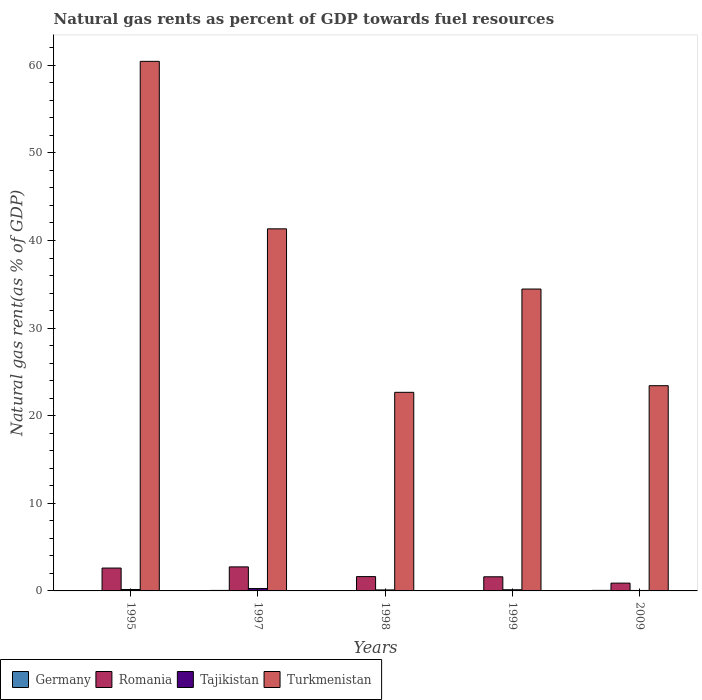How many different coloured bars are there?
Your answer should be compact. 4. Are the number of bars on each tick of the X-axis equal?
Provide a short and direct response. Yes. How many bars are there on the 4th tick from the right?
Your answer should be very brief. 4. What is the label of the 1st group of bars from the left?
Ensure brevity in your answer.  1995. In how many cases, is the number of bars for a given year not equal to the number of legend labels?
Keep it short and to the point. 0. What is the natural gas rent in Tajikistan in 2009?
Provide a short and direct response. 0.05. Across all years, what is the maximum natural gas rent in Tajikistan?
Give a very brief answer. 0.27. Across all years, what is the minimum natural gas rent in Romania?
Offer a very short reply. 0.89. In which year was the natural gas rent in Turkmenistan minimum?
Keep it short and to the point. 1998. What is the total natural gas rent in Germany in the graph?
Your response must be concise. 0.24. What is the difference between the natural gas rent in Tajikistan in 1999 and that in 2009?
Provide a short and direct response. 0.08. What is the difference between the natural gas rent in Turkmenistan in 1997 and the natural gas rent in Romania in 2009?
Your response must be concise. 40.44. What is the average natural gas rent in Germany per year?
Keep it short and to the point. 0.05. In the year 1998, what is the difference between the natural gas rent in Tajikistan and natural gas rent in Turkmenistan?
Provide a short and direct response. -22.56. In how many years, is the natural gas rent in Tajikistan greater than 40 %?
Make the answer very short. 0. What is the ratio of the natural gas rent in Turkmenistan in 1995 to that in 2009?
Make the answer very short. 2.58. Is the difference between the natural gas rent in Tajikistan in 1995 and 2009 greater than the difference between the natural gas rent in Turkmenistan in 1995 and 2009?
Give a very brief answer. No. What is the difference between the highest and the second highest natural gas rent in Tajikistan?
Make the answer very short. 0.11. What is the difference between the highest and the lowest natural gas rent in Romania?
Your answer should be very brief. 1.85. In how many years, is the natural gas rent in Turkmenistan greater than the average natural gas rent in Turkmenistan taken over all years?
Make the answer very short. 2. Is the sum of the natural gas rent in Romania in 1997 and 1999 greater than the maximum natural gas rent in Tajikistan across all years?
Offer a terse response. Yes. Is it the case that in every year, the sum of the natural gas rent in Germany and natural gas rent in Tajikistan is greater than the sum of natural gas rent in Romania and natural gas rent in Turkmenistan?
Your answer should be very brief. No. What does the 3rd bar from the right in 1997 represents?
Your answer should be compact. Romania. Are all the bars in the graph horizontal?
Provide a succinct answer. No. How many years are there in the graph?
Keep it short and to the point. 5. Are the values on the major ticks of Y-axis written in scientific E-notation?
Your answer should be compact. No. Does the graph contain grids?
Your answer should be very brief. No. How many legend labels are there?
Offer a very short reply. 4. What is the title of the graph?
Your answer should be compact. Natural gas rents as percent of GDP towards fuel resources. What is the label or title of the Y-axis?
Your answer should be very brief. Natural gas rent(as % of GDP). What is the Natural gas rent(as % of GDP) of Germany in 1995?
Your answer should be very brief. 0.04. What is the Natural gas rent(as % of GDP) of Romania in 1995?
Make the answer very short. 2.61. What is the Natural gas rent(as % of GDP) in Tajikistan in 1995?
Your answer should be compact. 0.16. What is the Natural gas rent(as % of GDP) in Turkmenistan in 1995?
Ensure brevity in your answer.  60.45. What is the Natural gas rent(as % of GDP) in Germany in 1997?
Your response must be concise. 0.06. What is the Natural gas rent(as % of GDP) in Romania in 1997?
Offer a terse response. 2.74. What is the Natural gas rent(as % of GDP) of Tajikistan in 1997?
Your answer should be very brief. 0.27. What is the Natural gas rent(as % of GDP) in Turkmenistan in 1997?
Your response must be concise. 41.33. What is the Natural gas rent(as % of GDP) in Germany in 1998?
Keep it short and to the point. 0.04. What is the Natural gas rent(as % of GDP) of Romania in 1998?
Give a very brief answer. 1.64. What is the Natural gas rent(as % of GDP) in Tajikistan in 1998?
Your response must be concise. 0.11. What is the Natural gas rent(as % of GDP) in Turkmenistan in 1998?
Your response must be concise. 22.67. What is the Natural gas rent(as % of GDP) of Germany in 1999?
Ensure brevity in your answer.  0.04. What is the Natural gas rent(as % of GDP) of Romania in 1999?
Keep it short and to the point. 1.61. What is the Natural gas rent(as % of GDP) of Tajikistan in 1999?
Your response must be concise. 0.13. What is the Natural gas rent(as % of GDP) in Turkmenistan in 1999?
Keep it short and to the point. 34.46. What is the Natural gas rent(as % of GDP) in Germany in 2009?
Offer a very short reply. 0.06. What is the Natural gas rent(as % of GDP) in Romania in 2009?
Provide a succinct answer. 0.89. What is the Natural gas rent(as % of GDP) of Tajikistan in 2009?
Your response must be concise. 0.05. What is the Natural gas rent(as % of GDP) of Turkmenistan in 2009?
Make the answer very short. 23.42. Across all years, what is the maximum Natural gas rent(as % of GDP) in Germany?
Your response must be concise. 0.06. Across all years, what is the maximum Natural gas rent(as % of GDP) in Romania?
Ensure brevity in your answer.  2.74. Across all years, what is the maximum Natural gas rent(as % of GDP) of Tajikistan?
Your answer should be compact. 0.27. Across all years, what is the maximum Natural gas rent(as % of GDP) of Turkmenistan?
Your answer should be very brief. 60.45. Across all years, what is the minimum Natural gas rent(as % of GDP) in Germany?
Offer a very short reply. 0.04. Across all years, what is the minimum Natural gas rent(as % of GDP) in Romania?
Provide a short and direct response. 0.89. Across all years, what is the minimum Natural gas rent(as % of GDP) in Tajikistan?
Keep it short and to the point. 0.05. Across all years, what is the minimum Natural gas rent(as % of GDP) in Turkmenistan?
Keep it short and to the point. 22.67. What is the total Natural gas rent(as % of GDP) of Germany in the graph?
Your answer should be very brief. 0.24. What is the total Natural gas rent(as % of GDP) of Romania in the graph?
Make the answer very short. 9.49. What is the total Natural gas rent(as % of GDP) in Tajikistan in the graph?
Your response must be concise. 0.73. What is the total Natural gas rent(as % of GDP) of Turkmenistan in the graph?
Keep it short and to the point. 182.33. What is the difference between the Natural gas rent(as % of GDP) of Germany in 1995 and that in 1997?
Provide a short and direct response. -0.02. What is the difference between the Natural gas rent(as % of GDP) in Romania in 1995 and that in 1997?
Your answer should be compact. -0.13. What is the difference between the Natural gas rent(as % of GDP) of Tajikistan in 1995 and that in 1997?
Your response must be concise. -0.11. What is the difference between the Natural gas rent(as % of GDP) of Turkmenistan in 1995 and that in 1997?
Ensure brevity in your answer.  19.12. What is the difference between the Natural gas rent(as % of GDP) in Germany in 1995 and that in 1998?
Give a very brief answer. -0.01. What is the difference between the Natural gas rent(as % of GDP) of Romania in 1995 and that in 1998?
Ensure brevity in your answer.  0.98. What is the difference between the Natural gas rent(as % of GDP) of Tajikistan in 1995 and that in 1998?
Give a very brief answer. 0.05. What is the difference between the Natural gas rent(as % of GDP) of Turkmenistan in 1995 and that in 1998?
Your answer should be compact. 37.78. What is the difference between the Natural gas rent(as % of GDP) in Germany in 1995 and that in 1999?
Give a very brief answer. -0. What is the difference between the Natural gas rent(as % of GDP) of Tajikistan in 1995 and that in 1999?
Ensure brevity in your answer.  0.03. What is the difference between the Natural gas rent(as % of GDP) of Turkmenistan in 1995 and that in 1999?
Your answer should be compact. 25.99. What is the difference between the Natural gas rent(as % of GDP) in Germany in 1995 and that in 2009?
Provide a succinct answer. -0.02. What is the difference between the Natural gas rent(as % of GDP) in Romania in 1995 and that in 2009?
Your answer should be very brief. 1.72. What is the difference between the Natural gas rent(as % of GDP) in Tajikistan in 1995 and that in 2009?
Your response must be concise. 0.11. What is the difference between the Natural gas rent(as % of GDP) in Turkmenistan in 1995 and that in 2009?
Provide a short and direct response. 37.02. What is the difference between the Natural gas rent(as % of GDP) in Germany in 1997 and that in 1998?
Give a very brief answer. 0.02. What is the difference between the Natural gas rent(as % of GDP) in Romania in 1997 and that in 1998?
Your answer should be very brief. 1.11. What is the difference between the Natural gas rent(as % of GDP) of Tajikistan in 1997 and that in 1998?
Your answer should be compact. 0.16. What is the difference between the Natural gas rent(as % of GDP) in Turkmenistan in 1997 and that in 1998?
Your answer should be compact. 18.66. What is the difference between the Natural gas rent(as % of GDP) in Germany in 1997 and that in 1999?
Give a very brief answer. 0.02. What is the difference between the Natural gas rent(as % of GDP) in Romania in 1997 and that in 1999?
Give a very brief answer. 1.13. What is the difference between the Natural gas rent(as % of GDP) of Tajikistan in 1997 and that in 1999?
Give a very brief answer. 0.14. What is the difference between the Natural gas rent(as % of GDP) of Turkmenistan in 1997 and that in 1999?
Make the answer very short. 6.87. What is the difference between the Natural gas rent(as % of GDP) of Germany in 1997 and that in 2009?
Your response must be concise. -0. What is the difference between the Natural gas rent(as % of GDP) of Romania in 1997 and that in 2009?
Give a very brief answer. 1.85. What is the difference between the Natural gas rent(as % of GDP) in Tajikistan in 1997 and that in 2009?
Ensure brevity in your answer.  0.22. What is the difference between the Natural gas rent(as % of GDP) in Turkmenistan in 1997 and that in 2009?
Your response must be concise. 17.9. What is the difference between the Natural gas rent(as % of GDP) in Germany in 1998 and that in 1999?
Offer a very short reply. 0. What is the difference between the Natural gas rent(as % of GDP) of Romania in 1998 and that in 1999?
Your answer should be very brief. 0.02. What is the difference between the Natural gas rent(as % of GDP) in Tajikistan in 1998 and that in 1999?
Provide a short and direct response. -0.02. What is the difference between the Natural gas rent(as % of GDP) of Turkmenistan in 1998 and that in 1999?
Give a very brief answer. -11.79. What is the difference between the Natural gas rent(as % of GDP) of Germany in 1998 and that in 2009?
Provide a succinct answer. -0.02. What is the difference between the Natural gas rent(as % of GDP) in Romania in 1998 and that in 2009?
Make the answer very short. 0.74. What is the difference between the Natural gas rent(as % of GDP) in Tajikistan in 1998 and that in 2009?
Give a very brief answer. 0.06. What is the difference between the Natural gas rent(as % of GDP) of Turkmenistan in 1998 and that in 2009?
Offer a very short reply. -0.76. What is the difference between the Natural gas rent(as % of GDP) in Germany in 1999 and that in 2009?
Give a very brief answer. -0.02. What is the difference between the Natural gas rent(as % of GDP) in Romania in 1999 and that in 2009?
Make the answer very short. 0.72. What is the difference between the Natural gas rent(as % of GDP) in Tajikistan in 1999 and that in 2009?
Give a very brief answer. 0.08. What is the difference between the Natural gas rent(as % of GDP) of Turkmenistan in 1999 and that in 2009?
Provide a short and direct response. 11.03. What is the difference between the Natural gas rent(as % of GDP) in Germany in 1995 and the Natural gas rent(as % of GDP) in Romania in 1997?
Your answer should be very brief. -2.71. What is the difference between the Natural gas rent(as % of GDP) in Germany in 1995 and the Natural gas rent(as % of GDP) in Tajikistan in 1997?
Provide a succinct answer. -0.23. What is the difference between the Natural gas rent(as % of GDP) of Germany in 1995 and the Natural gas rent(as % of GDP) of Turkmenistan in 1997?
Your answer should be very brief. -41.29. What is the difference between the Natural gas rent(as % of GDP) in Romania in 1995 and the Natural gas rent(as % of GDP) in Tajikistan in 1997?
Offer a terse response. 2.34. What is the difference between the Natural gas rent(as % of GDP) of Romania in 1995 and the Natural gas rent(as % of GDP) of Turkmenistan in 1997?
Offer a terse response. -38.72. What is the difference between the Natural gas rent(as % of GDP) in Tajikistan in 1995 and the Natural gas rent(as % of GDP) in Turkmenistan in 1997?
Your response must be concise. -41.17. What is the difference between the Natural gas rent(as % of GDP) in Germany in 1995 and the Natural gas rent(as % of GDP) in Romania in 1998?
Your answer should be compact. -1.6. What is the difference between the Natural gas rent(as % of GDP) of Germany in 1995 and the Natural gas rent(as % of GDP) of Tajikistan in 1998?
Offer a terse response. -0.08. What is the difference between the Natural gas rent(as % of GDP) of Germany in 1995 and the Natural gas rent(as % of GDP) of Turkmenistan in 1998?
Your answer should be very brief. -22.63. What is the difference between the Natural gas rent(as % of GDP) of Romania in 1995 and the Natural gas rent(as % of GDP) of Tajikistan in 1998?
Your answer should be very brief. 2.5. What is the difference between the Natural gas rent(as % of GDP) of Romania in 1995 and the Natural gas rent(as % of GDP) of Turkmenistan in 1998?
Offer a very short reply. -20.06. What is the difference between the Natural gas rent(as % of GDP) in Tajikistan in 1995 and the Natural gas rent(as % of GDP) in Turkmenistan in 1998?
Offer a terse response. -22.51. What is the difference between the Natural gas rent(as % of GDP) of Germany in 1995 and the Natural gas rent(as % of GDP) of Romania in 1999?
Your response must be concise. -1.58. What is the difference between the Natural gas rent(as % of GDP) in Germany in 1995 and the Natural gas rent(as % of GDP) in Tajikistan in 1999?
Offer a very short reply. -0.09. What is the difference between the Natural gas rent(as % of GDP) in Germany in 1995 and the Natural gas rent(as % of GDP) in Turkmenistan in 1999?
Offer a terse response. -34.42. What is the difference between the Natural gas rent(as % of GDP) of Romania in 1995 and the Natural gas rent(as % of GDP) of Tajikistan in 1999?
Your answer should be compact. 2.48. What is the difference between the Natural gas rent(as % of GDP) of Romania in 1995 and the Natural gas rent(as % of GDP) of Turkmenistan in 1999?
Your answer should be compact. -31.85. What is the difference between the Natural gas rent(as % of GDP) in Tajikistan in 1995 and the Natural gas rent(as % of GDP) in Turkmenistan in 1999?
Offer a very short reply. -34.3. What is the difference between the Natural gas rent(as % of GDP) in Germany in 1995 and the Natural gas rent(as % of GDP) in Romania in 2009?
Provide a short and direct response. -0.85. What is the difference between the Natural gas rent(as % of GDP) of Germany in 1995 and the Natural gas rent(as % of GDP) of Tajikistan in 2009?
Provide a short and direct response. -0.02. What is the difference between the Natural gas rent(as % of GDP) in Germany in 1995 and the Natural gas rent(as % of GDP) in Turkmenistan in 2009?
Ensure brevity in your answer.  -23.39. What is the difference between the Natural gas rent(as % of GDP) in Romania in 1995 and the Natural gas rent(as % of GDP) in Tajikistan in 2009?
Provide a succinct answer. 2.56. What is the difference between the Natural gas rent(as % of GDP) of Romania in 1995 and the Natural gas rent(as % of GDP) of Turkmenistan in 2009?
Ensure brevity in your answer.  -20.81. What is the difference between the Natural gas rent(as % of GDP) of Tajikistan in 1995 and the Natural gas rent(as % of GDP) of Turkmenistan in 2009?
Keep it short and to the point. -23.27. What is the difference between the Natural gas rent(as % of GDP) of Germany in 1997 and the Natural gas rent(as % of GDP) of Romania in 1998?
Give a very brief answer. -1.58. What is the difference between the Natural gas rent(as % of GDP) of Germany in 1997 and the Natural gas rent(as % of GDP) of Tajikistan in 1998?
Offer a terse response. -0.06. What is the difference between the Natural gas rent(as % of GDP) of Germany in 1997 and the Natural gas rent(as % of GDP) of Turkmenistan in 1998?
Offer a very short reply. -22.61. What is the difference between the Natural gas rent(as % of GDP) of Romania in 1997 and the Natural gas rent(as % of GDP) of Tajikistan in 1998?
Ensure brevity in your answer.  2.63. What is the difference between the Natural gas rent(as % of GDP) of Romania in 1997 and the Natural gas rent(as % of GDP) of Turkmenistan in 1998?
Your answer should be very brief. -19.93. What is the difference between the Natural gas rent(as % of GDP) in Tajikistan in 1997 and the Natural gas rent(as % of GDP) in Turkmenistan in 1998?
Your answer should be compact. -22.4. What is the difference between the Natural gas rent(as % of GDP) in Germany in 1997 and the Natural gas rent(as % of GDP) in Romania in 1999?
Keep it short and to the point. -1.55. What is the difference between the Natural gas rent(as % of GDP) of Germany in 1997 and the Natural gas rent(as % of GDP) of Tajikistan in 1999?
Give a very brief answer. -0.07. What is the difference between the Natural gas rent(as % of GDP) in Germany in 1997 and the Natural gas rent(as % of GDP) in Turkmenistan in 1999?
Make the answer very short. -34.4. What is the difference between the Natural gas rent(as % of GDP) in Romania in 1997 and the Natural gas rent(as % of GDP) in Tajikistan in 1999?
Your response must be concise. 2.61. What is the difference between the Natural gas rent(as % of GDP) in Romania in 1997 and the Natural gas rent(as % of GDP) in Turkmenistan in 1999?
Keep it short and to the point. -31.71. What is the difference between the Natural gas rent(as % of GDP) of Tajikistan in 1997 and the Natural gas rent(as % of GDP) of Turkmenistan in 1999?
Provide a short and direct response. -34.19. What is the difference between the Natural gas rent(as % of GDP) of Germany in 1997 and the Natural gas rent(as % of GDP) of Romania in 2009?
Give a very brief answer. -0.83. What is the difference between the Natural gas rent(as % of GDP) of Germany in 1997 and the Natural gas rent(as % of GDP) of Tajikistan in 2009?
Offer a terse response. 0.01. What is the difference between the Natural gas rent(as % of GDP) of Germany in 1997 and the Natural gas rent(as % of GDP) of Turkmenistan in 2009?
Provide a short and direct response. -23.37. What is the difference between the Natural gas rent(as % of GDP) in Romania in 1997 and the Natural gas rent(as % of GDP) in Tajikistan in 2009?
Offer a very short reply. 2.69. What is the difference between the Natural gas rent(as % of GDP) in Romania in 1997 and the Natural gas rent(as % of GDP) in Turkmenistan in 2009?
Offer a terse response. -20.68. What is the difference between the Natural gas rent(as % of GDP) of Tajikistan in 1997 and the Natural gas rent(as % of GDP) of Turkmenistan in 2009?
Your answer should be compact. -23.15. What is the difference between the Natural gas rent(as % of GDP) of Germany in 1998 and the Natural gas rent(as % of GDP) of Romania in 1999?
Ensure brevity in your answer.  -1.57. What is the difference between the Natural gas rent(as % of GDP) in Germany in 1998 and the Natural gas rent(as % of GDP) in Tajikistan in 1999?
Provide a succinct answer. -0.09. What is the difference between the Natural gas rent(as % of GDP) in Germany in 1998 and the Natural gas rent(as % of GDP) in Turkmenistan in 1999?
Keep it short and to the point. -34.42. What is the difference between the Natural gas rent(as % of GDP) in Romania in 1998 and the Natural gas rent(as % of GDP) in Tajikistan in 1999?
Ensure brevity in your answer.  1.5. What is the difference between the Natural gas rent(as % of GDP) of Romania in 1998 and the Natural gas rent(as % of GDP) of Turkmenistan in 1999?
Offer a very short reply. -32.82. What is the difference between the Natural gas rent(as % of GDP) of Tajikistan in 1998 and the Natural gas rent(as % of GDP) of Turkmenistan in 1999?
Your answer should be compact. -34.34. What is the difference between the Natural gas rent(as % of GDP) of Germany in 1998 and the Natural gas rent(as % of GDP) of Romania in 2009?
Offer a terse response. -0.85. What is the difference between the Natural gas rent(as % of GDP) of Germany in 1998 and the Natural gas rent(as % of GDP) of Tajikistan in 2009?
Offer a very short reply. -0.01. What is the difference between the Natural gas rent(as % of GDP) in Germany in 1998 and the Natural gas rent(as % of GDP) in Turkmenistan in 2009?
Your answer should be very brief. -23.38. What is the difference between the Natural gas rent(as % of GDP) in Romania in 1998 and the Natural gas rent(as % of GDP) in Tajikistan in 2009?
Keep it short and to the point. 1.58. What is the difference between the Natural gas rent(as % of GDP) of Romania in 1998 and the Natural gas rent(as % of GDP) of Turkmenistan in 2009?
Offer a terse response. -21.79. What is the difference between the Natural gas rent(as % of GDP) of Tajikistan in 1998 and the Natural gas rent(as % of GDP) of Turkmenistan in 2009?
Offer a very short reply. -23.31. What is the difference between the Natural gas rent(as % of GDP) of Germany in 1999 and the Natural gas rent(as % of GDP) of Romania in 2009?
Your response must be concise. -0.85. What is the difference between the Natural gas rent(as % of GDP) in Germany in 1999 and the Natural gas rent(as % of GDP) in Tajikistan in 2009?
Keep it short and to the point. -0.01. What is the difference between the Natural gas rent(as % of GDP) of Germany in 1999 and the Natural gas rent(as % of GDP) of Turkmenistan in 2009?
Your answer should be very brief. -23.39. What is the difference between the Natural gas rent(as % of GDP) of Romania in 1999 and the Natural gas rent(as % of GDP) of Tajikistan in 2009?
Ensure brevity in your answer.  1.56. What is the difference between the Natural gas rent(as % of GDP) of Romania in 1999 and the Natural gas rent(as % of GDP) of Turkmenistan in 2009?
Make the answer very short. -21.81. What is the difference between the Natural gas rent(as % of GDP) of Tajikistan in 1999 and the Natural gas rent(as % of GDP) of Turkmenistan in 2009?
Your answer should be very brief. -23.29. What is the average Natural gas rent(as % of GDP) in Germany per year?
Your answer should be compact. 0.05. What is the average Natural gas rent(as % of GDP) in Romania per year?
Provide a succinct answer. 1.9. What is the average Natural gas rent(as % of GDP) in Tajikistan per year?
Provide a succinct answer. 0.15. What is the average Natural gas rent(as % of GDP) of Turkmenistan per year?
Your response must be concise. 36.47. In the year 1995, what is the difference between the Natural gas rent(as % of GDP) in Germany and Natural gas rent(as % of GDP) in Romania?
Offer a terse response. -2.57. In the year 1995, what is the difference between the Natural gas rent(as % of GDP) of Germany and Natural gas rent(as % of GDP) of Tajikistan?
Your answer should be very brief. -0.12. In the year 1995, what is the difference between the Natural gas rent(as % of GDP) in Germany and Natural gas rent(as % of GDP) in Turkmenistan?
Your response must be concise. -60.41. In the year 1995, what is the difference between the Natural gas rent(as % of GDP) of Romania and Natural gas rent(as % of GDP) of Tajikistan?
Your answer should be compact. 2.45. In the year 1995, what is the difference between the Natural gas rent(as % of GDP) of Romania and Natural gas rent(as % of GDP) of Turkmenistan?
Your answer should be compact. -57.84. In the year 1995, what is the difference between the Natural gas rent(as % of GDP) of Tajikistan and Natural gas rent(as % of GDP) of Turkmenistan?
Make the answer very short. -60.29. In the year 1997, what is the difference between the Natural gas rent(as % of GDP) of Germany and Natural gas rent(as % of GDP) of Romania?
Provide a succinct answer. -2.69. In the year 1997, what is the difference between the Natural gas rent(as % of GDP) in Germany and Natural gas rent(as % of GDP) in Tajikistan?
Your answer should be compact. -0.21. In the year 1997, what is the difference between the Natural gas rent(as % of GDP) of Germany and Natural gas rent(as % of GDP) of Turkmenistan?
Your answer should be very brief. -41.27. In the year 1997, what is the difference between the Natural gas rent(as % of GDP) of Romania and Natural gas rent(as % of GDP) of Tajikistan?
Keep it short and to the point. 2.47. In the year 1997, what is the difference between the Natural gas rent(as % of GDP) in Romania and Natural gas rent(as % of GDP) in Turkmenistan?
Keep it short and to the point. -38.59. In the year 1997, what is the difference between the Natural gas rent(as % of GDP) in Tajikistan and Natural gas rent(as % of GDP) in Turkmenistan?
Your answer should be compact. -41.06. In the year 1998, what is the difference between the Natural gas rent(as % of GDP) in Germany and Natural gas rent(as % of GDP) in Romania?
Make the answer very short. -1.59. In the year 1998, what is the difference between the Natural gas rent(as % of GDP) in Germany and Natural gas rent(as % of GDP) in Tajikistan?
Keep it short and to the point. -0.07. In the year 1998, what is the difference between the Natural gas rent(as % of GDP) in Germany and Natural gas rent(as % of GDP) in Turkmenistan?
Your answer should be very brief. -22.63. In the year 1998, what is the difference between the Natural gas rent(as % of GDP) of Romania and Natural gas rent(as % of GDP) of Tajikistan?
Provide a short and direct response. 1.52. In the year 1998, what is the difference between the Natural gas rent(as % of GDP) in Romania and Natural gas rent(as % of GDP) in Turkmenistan?
Your response must be concise. -21.03. In the year 1998, what is the difference between the Natural gas rent(as % of GDP) in Tajikistan and Natural gas rent(as % of GDP) in Turkmenistan?
Your answer should be very brief. -22.56. In the year 1999, what is the difference between the Natural gas rent(as % of GDP) of Germany and Natural gas rent(as % of GDP) of Romania?
Make the answer very short. -1.57. In the year 1999, what is the difference between the Natural gas rent(as % of GDP) of Germany and Natural gas rent(as % of GDP) of Tajikistan?
Keep it short and to the point. -0.09. In the year 1999, what is the difference between the Natural gas rent(as % of GDP) in Germany and Natural gas rent(as % of GDP) in Turkmenistan?
Provide a short and direct response. -34.42. In the year 1999, what is the difference between the Natural gas rent(as % of GDP) of Romania and Natural gas rent(as % of GDP) of Tajikistan?
Make the answer very short. 1.48. In the year 1999, what is the difference between the Natural gas rent(as % of GDP) in Romania and Natural gas rent(as % of GDP) in Turkmenistan?
Provide a succinct answer. -32.85. In the year 1999, what is the difference between the Natural gas rent(as % of GDP) of Tajikistan and Natural gas rent(as % of GDP) of Turkmenistan?
Offer a very short reply. -34.33. In the year 2009, what is the difference between the Natural gas rent(as % of GDP) in Germany and Natural gas rent(as % of GDP) in Romania?
Provide a short and direct response. -0.83. In the year 2009, what is the difference between the Natural gas rent(as % of GDP) of Germany and Natural gas rent(as % of GDP) of Tajikistan?
Offer a very short reply. 0.01. In the year 2009, what is the difference between the Natural gas rent(as % of GDP) in Germany and Natural gas rent(as % of GDP) in Turkmenistan?
Offer a very short reply. -23.36. In the year 2009, what is the difference between the Natural gas rent(as % of GDP) in Romania and Natural gas rent(as % of GDP) in Tajikistan?
Ensure brevity in your answer.  0.84. In the year 2009, what is the difference between the Natural gas rent(as % of GDP) in Romania and Natural gas rent(as % of GDP) in Turkmenistan?
Your answer should be very brief. -22.53. In the year 2009, what is the difference between the Natural gas rent(as % of GDP) in Tajikistan and Natural gas rent(as % of GDP) in Turkmenistan?
Provide a succinct answer. -23.37. What is the ratio of the Natural gas rent(as % of GDP) of Germany in 1995 to that in 1997?
Keep it short and to the point. 0.64. What is the ratio of the Natural gas rent(as % of GDP) of Romania in 1995 to that in 1997?
Keep it short and to the point. 0.95. What is the ratio of the Natural gas rent(as % of GDP) of Tajikistan in 1995 to that in 1997?
Keep it short and to the point. 0.58. What is the ratio of the Natural gas rent(as % of GDP) of Turkmenistan in 1995 to that in 1997?
Your answer should be very brief. 1.46. What is the ratio of the Natural gas rent(as % of GDP) in Germany in 1995 to that in 1998?
Give a very brief answer. 0.87. What is the ratio of the Natural gas rent(as % of GDP) in Romania in 1995 to that in 1998?
Your answer should be compact. 1.6. What is the ratio of the Natural gas rent(as % of GDP) of Tajikistan in 1995 to that in 1998?
Give a very brief answer. 1.4. What is the ratio of the Natural gas rent(as % of GDP) in Turkmenistan in 1995 to that in 1998?
Provide a short and direct response. 2.67. What is the ratio of the Natural gas rent(as % of GDP) in Germany in 1995 to that in 1999?
Your answer should be very brief. 0.96. What is the ratio of the Natural gas rent(as % of GDP) in Romania in 1995 to that in 1999?
Your response must be concise. 1.62. What is the ratio of the Natural gas rent(as % of GDP) in Tajikistan in 1995 to that in 1999?
Make the answer very short. 1.21. What is the ratio of the Natural gas rent(as % of GDP) of Turkmenistan in 1995 to that in 1999?
Provide a succinct answer. 1.75. What is the ratio of the Natural gas rent(as % of GDP) of Germany in 1995 to that in 2009?
Keep it short and to the point. 0.6. What is the ratio of the Natural gas rent(as % of GDP) of Romania in 1995 to that in 2009?
Give a very brief answer. 2.93. What is the ratio of the Natural gas rent(as % of GDP) in Tajikistan in 1995 to that in 2009?
Provide a short and direct response. 3.03. What is the ratio of the Natural gas rent(as % of GDP) in Turkmenistan in 1995 to that in 2009?
Offer a terse response. 2.58. What is the ratio of the Natural gas rent(as % of GDP) in Germany in 1997 to that in 1998?
Keep it short and to the point. 1.37. What is the ratio of the Natural gas rent(as % of GDP) of Romania in 1997 to that in 1998?
Offer a terse response. 1.68. What is the ratio of the Natural gas rent(as % of GDP) in Tajikistan in 1997 to that in 1998?
Ensure brevity in your answer.  2.4. What is the ratio of the Natural gas rent(as % of GDP) of Turkmenistan in 1997 to that in 1998?
Your answer should be compact. 1.82. What is the ratio of the Natural gas rent(as % of GDP) of Germany in 1997 to that in 1999?
Offer a terse response. 1.51. What is the ratio of the Natural gas rent(as % of GDP) of Romania in 1997 to that in 1999?
Offer a very short reply. 1.7. What is the ratio of the Natural gas rent(as % of GDP) in Tajikistan in 1997 to that in 1999?
Your answer should be compact. 2.07. What is the ratio of the Natural gas rent(as % of GDP) of Turkmenistan in 1997 to that in 1999?
Offer a terse response. 1.2. What is the ratio of the Natural gas rent(as % of GDP) in Germany in 1997 to that in 2009?
Ensure brevity in your answer.  0.95. What is the ratio of the Natural gas rent(as % of GDP) in Romania in 1997 to that in 2009?
Your response must be concise. 3.08. What is the ratio of the Natural gas rent(as % of GDP) of Tajikistan in 1997 to that in 2009?
Your answer should be very brief. 5.18. What is the ratio of the Natural gas rent(as % of GDP) of Turkmenistan in 1997 to that in 2009?
Offer a very short reply. 1.76. What is the ratio of the Natural gas rent(as % of GDP) of Germany in 1998 to that in 1999?
Keep it short and to the point. 1.1. What is the ratio of the Natural gas rent(as % of GDP) of Romania in 1998 to that in 1999?
Your answer should be compact. 1.01. What is the ratio of the Natural gas rent(as % of GDP) in Tajikistan in 1998 to that in 1999?
Offer a very short reply. 0.86. What is the ratio of the Natural gas rent(as % of GDP) of Turkmenistan in 1998 to that in 1999?
Offer a very short reply. 0.66. What is the ratio of the Natural gas rent(as % of GDP) of Germany in 1998 to that in 2009?
Offer a terse response. 0.69. What is the ratio of the Natural gas rent(as % of GDP) of Romania in 1998 to that in 2009?
Provide a succinct answer. 1.83. What is the ratio of the Natural gas rent(as % of GDP) of Tajikistan in 1998 to that in 2009?
Provide a short and direct response. 2.16. What is the ratio of the Natural gas rent(as % of GDP) of Turkmenistan in 1998 to that in 2009?
Offer a very short reply. 0.97. What is the ratio of the Natural gas rent(as % of GDP) in Germany in 1999 to that in 2009?
Offer a terse response. 0.63. What is the ratio of the Natural gas rent(as % of GDP) in Romania in 1999 to that in 2009?
Your answer should be compact. 1.81. What is the ratio of the Natural gas rent(as % of GDP) in Tajikistan in 1999 to that in 2009?
Your answer should be compact. 2.51. What is the ratio of the Natural gas rent(as % of GDP) in Turkmenistan in 1999 to that in 2009?
Make the answer very short. 1.47. What is the difference between the highest and the second highest Natural gas rent(as % of GDP) in Germany?
Your response must be concise. 0. What is the difference between the highest and the second highest Natural gas rent(as % of GDP) in Romania?
Give a very brief answer. 0.13. What is the difference between the highest and the second highest Natural gas rent(as % of GDP) in Tajikistan?
Keep it short and to the point. 0.11. What is the difference between the highest and the second highest Natural gas rent(as % of GDP) of Turkmenistan?
Your answer should be compact. 19.12. What is the difference between the highest and the lowest Natural gas rent(as % of GDP) in Germany?
Provide a succinct answer. 0.02. What is the difference between the highest and the lowest Natural gas rent(as % of GDP) of Romania?
Keep it short and to the point. 1.85. What is the difference between the highest and the lowest Natural gas rent(as % of GDP) in Tajikistan?
Provide a succinct answer. 0.22. What is the difference between the highest and the lowest Natural gas rent(as % of GDP) in Turkmenistan?
Make the answer very short. 37.78. 